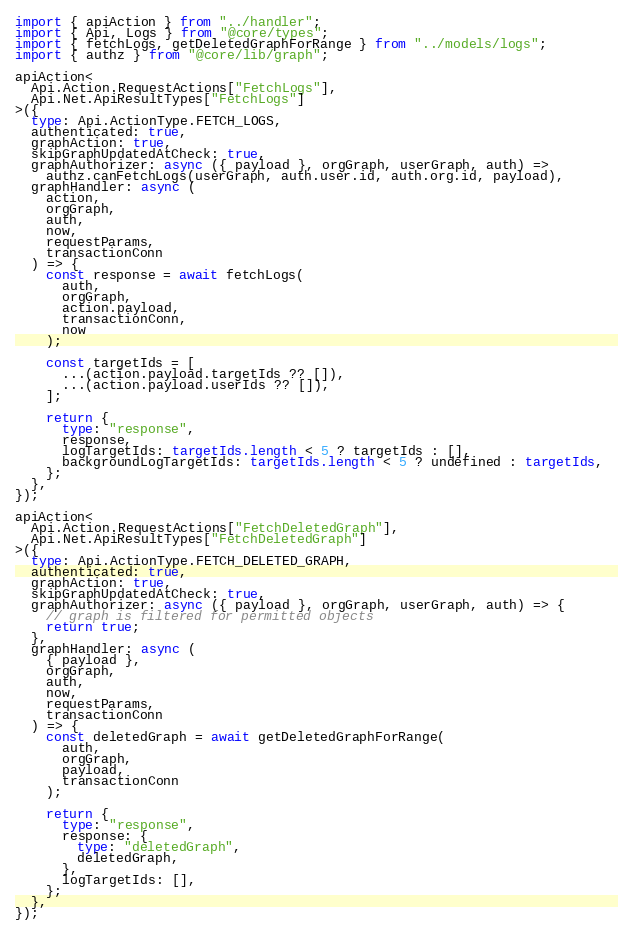Convert code to text. <code><loc_0><loc_0><loc_500><loc_500><_TypeScript_>import { apiAction } from "../handler";
import { Api, Logs } from "@core/types";
import { fetchLogs, getDeletedGraphForRange } from "../models/logs";
import { authz } from "@core/lib/graph";

apiAction<
  Api.Action.RequestActions["FetchLogs"],
  Api.Net.ApiResultTypes["FetchLogs"]
>({
  type: Api.ActionType.FETCH_LOGS,
  authenticated: true,
  graphAction: true,
  skipGraphUpdatedAtCheck: true,
  graphAuthorizer: async ({ payload }, orgGraph, userGraph, auth) =>
    authz.canFetchLogs(userGraph, auth.user.id, auth.org.id, payload),
  graphHandler: async (
    action,
    orgGraph,
    auth,
    now,
    requestParams,
    transactionConn
  ) => {
    const response = await fetchLogs(
      auth,
      orgGraph,
      action.payload,
      transactionConn,
      now
    );

    const targetIds = [
      ...(action.payload.targetIds ?? []),
      ...(action.payload.userIds ?? []),
    ];

    return {
      type: "response",
      response,
      logTargetIds: targetIds.length < 5 ? targetIds : [],
      backgroundLogTargetIds: targetIds.length < 5 ? undefined : targetIds,
    };
  },
});

apiAction<
  Api.Action.RequestActions["FetchDeletedGraph"],
  Api.Net.ApiResultTypes["FetchDeletedGraph"]
>({
  type: Api.ActionType.FETCH_DELETED_GRAPH,
  authenticated: true,
  graphAction: true,
  skipGraphUpdatedAtCheck: true,
  graphAuthorizer: async ({ payload }, orgGraph, userGraph, auth) => {
    // graph is filtered for permitted objects
    return true;
  },
  graphHandler: async (
    { payload },
    orgGraph,
    auth,
    now,
    requestParams,
    transactionConn
  ) => {
    const deletedGraph = await getDeletedGraphForRange(
      auth,
      orgGraph,
      payload,
      transactionConn
    );

    return {
      type: "response",
      response: {
        type: "deletedGraph",
        deletedGraph,
      },
      logTargetIds: [],
    };
  },
});
</code> 